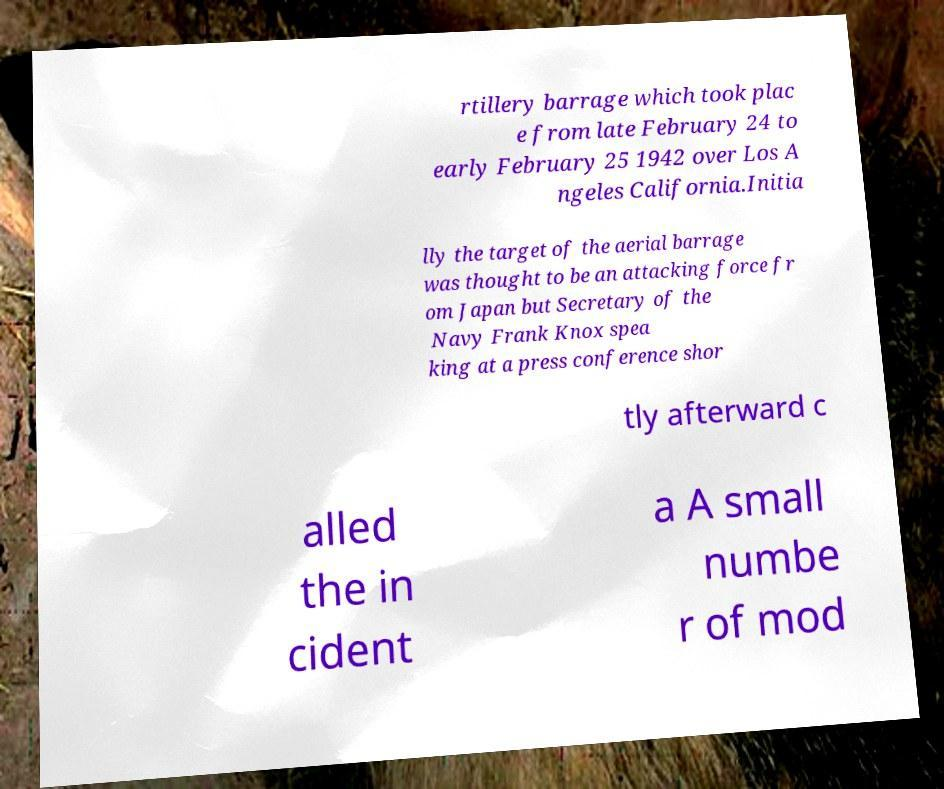There's text embedded in this image that I need extracted. Can you transcribe it verbatim? rtillery barrage which took plac e from late February 24 to early February 25 1942 over Los A ngeles California.Initia lly the target of the aerial barrage was thought to be an attacking force fr om Japan but Secretary of the Navy Frank Knox spea king at a press conference shor tly afterward c alled the in cident a A small numbe r of mod 